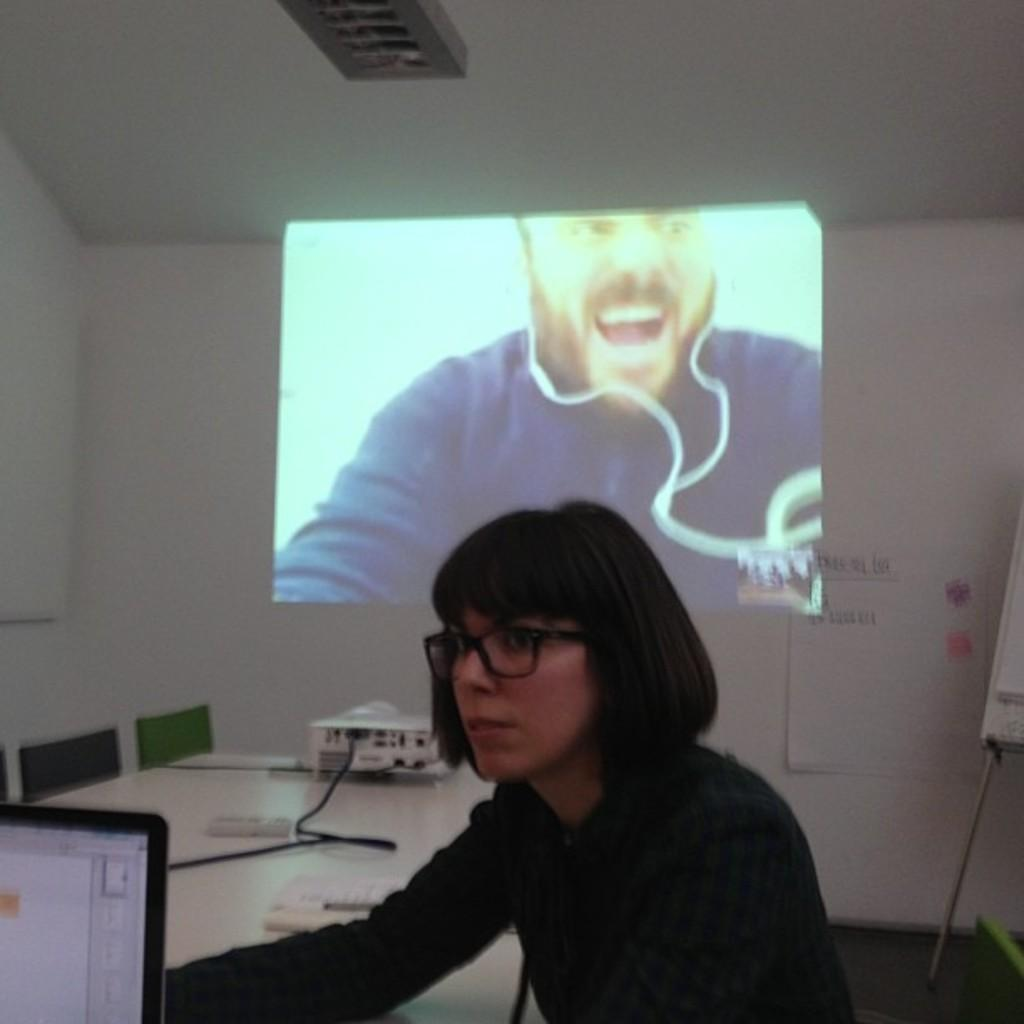Who is the main subject in the image? There is a woman in the image. What is the woman doing in the image? The woman is looking to the left side. Can you describe the woman's appearance? The woman is wearing spectacles. What can be seen in the middle of the image? There is a projected image in the middle of the image. Who is present in the projected image? A man is present in the projected image. What is the man in the projected image wearing? The man in the projected image is wearing earphones. What type of park is visible in the background of the image? There is no park visible in the background of the image. How does the woman's temper affect the projected image? The woman's temper is not mentioned in the image, and therefore its effect on the projected image cannot be determined. 